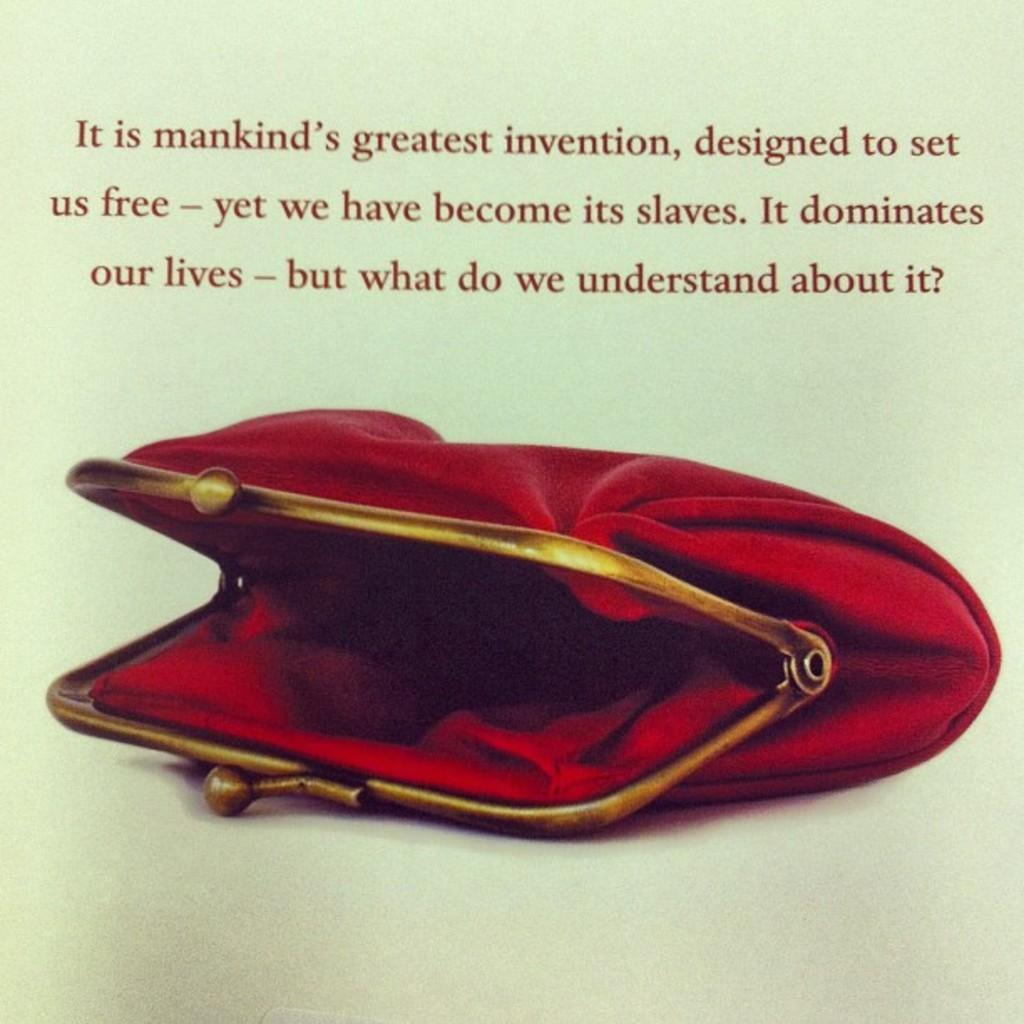Can you describe this image briefly? In this picture we can see a red color bag, there is some text here. 